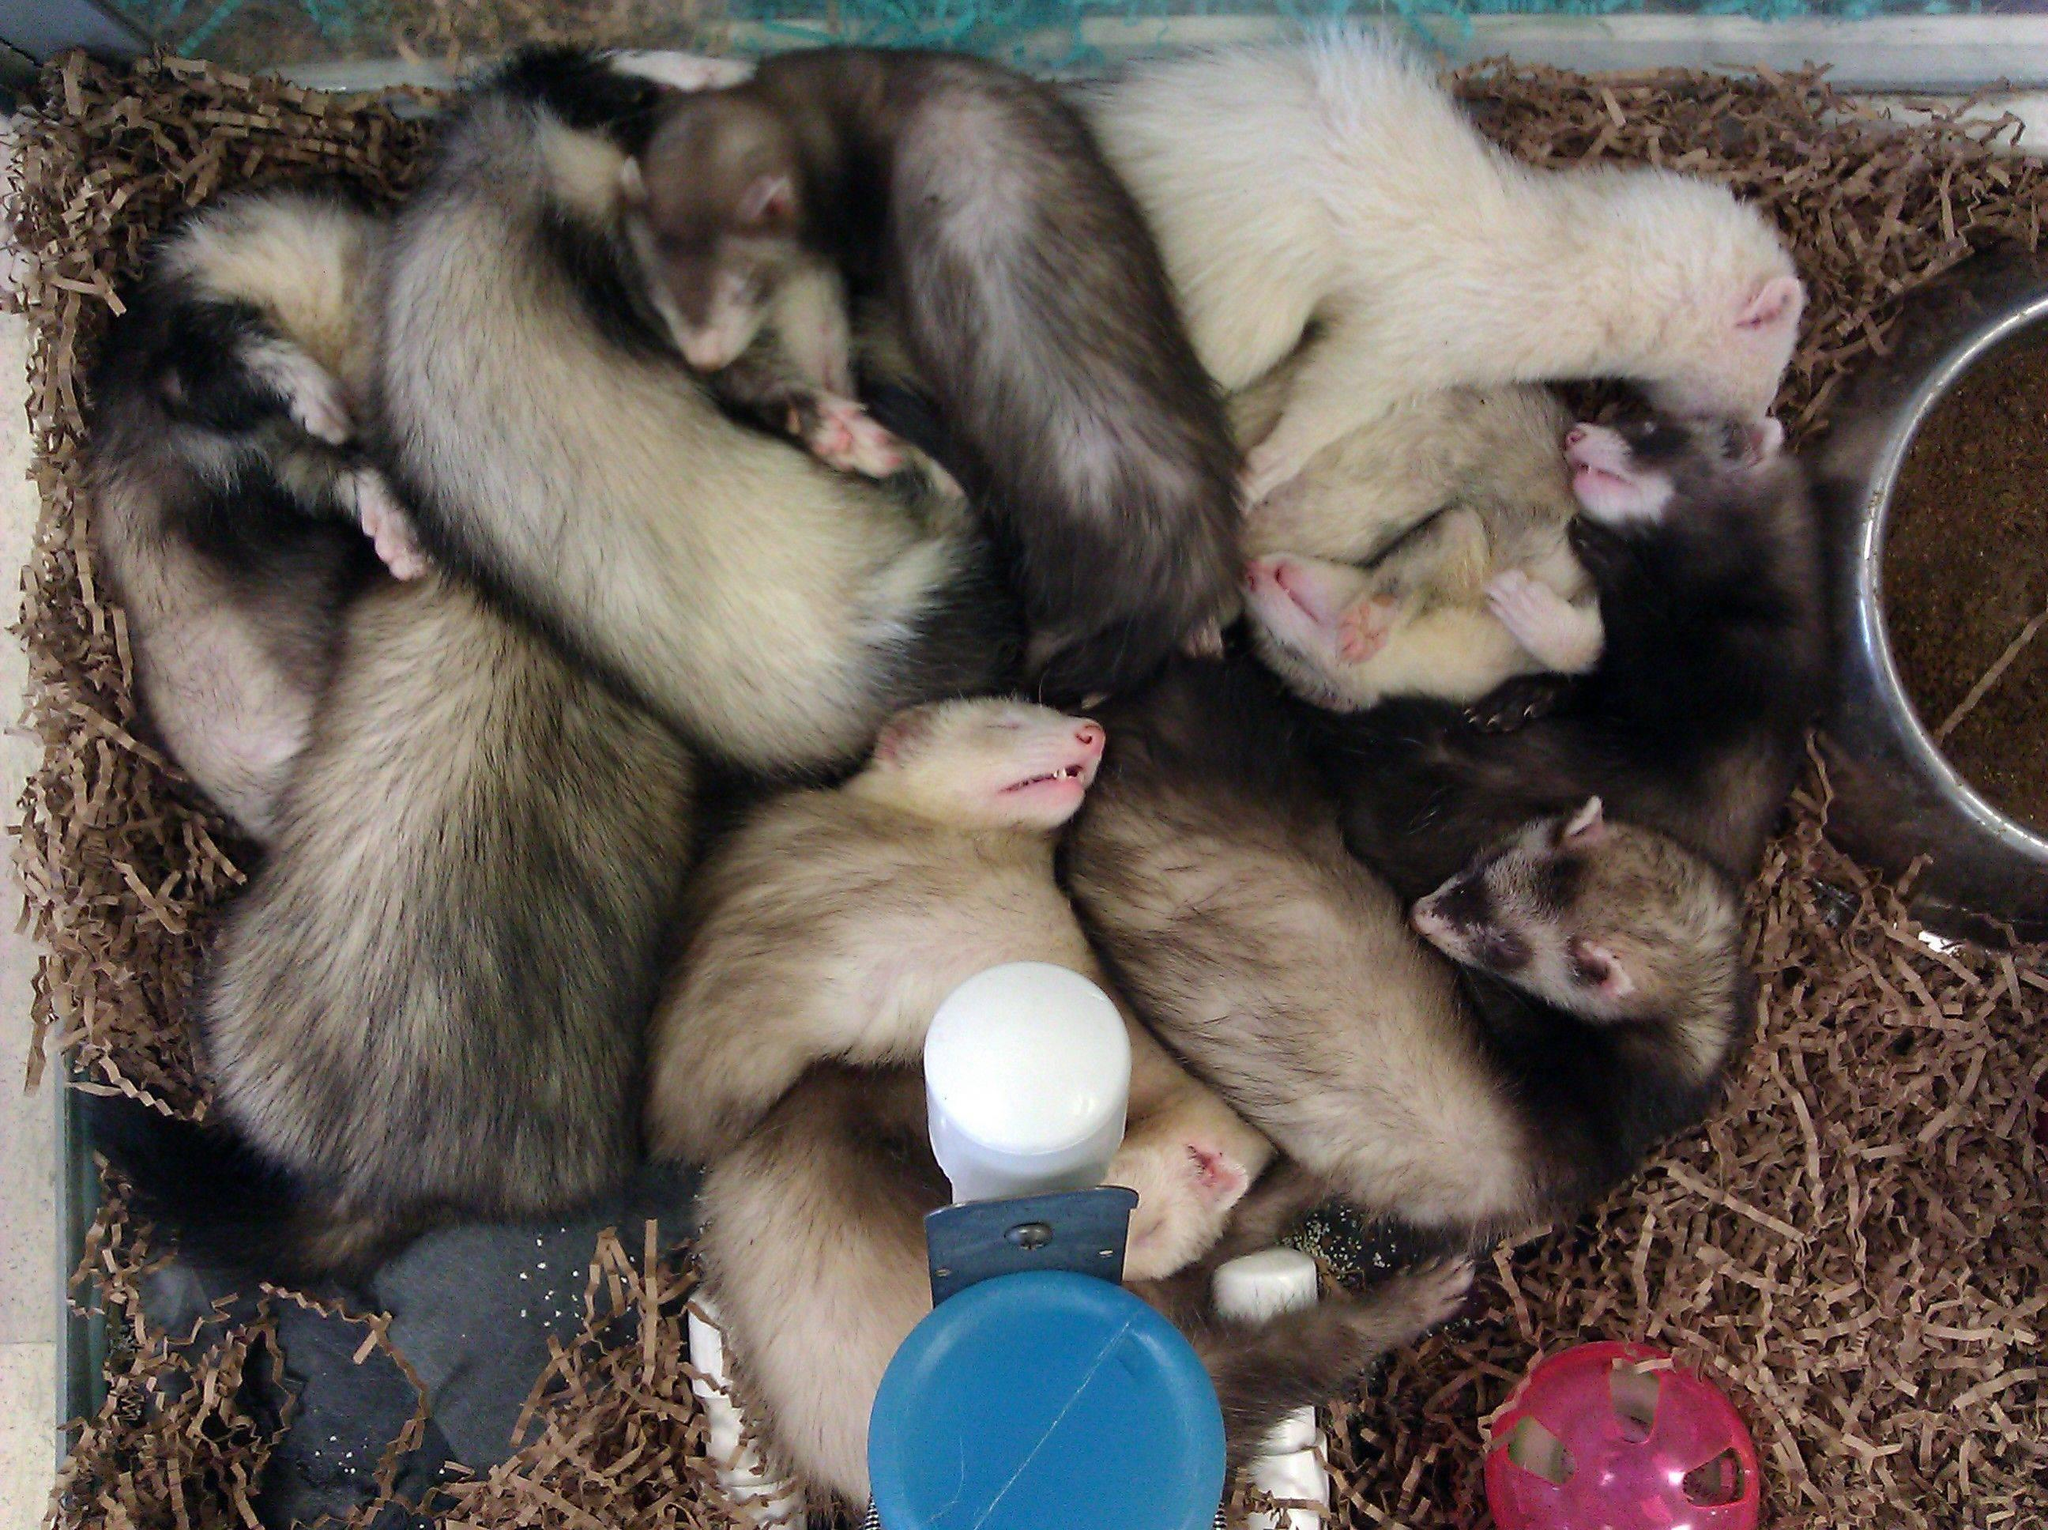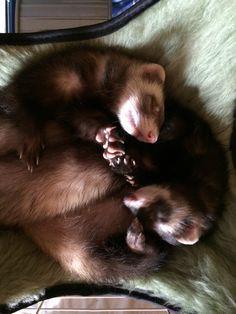The first image is the image on the left, the second image is the image on the right. For the images shown, is this caption "The animals in one of the images are near a window." true? Answer yes or no. No. The first image is the image on the left, the second image is the image on the right. Examine the images to the left and right. Is the description "All images show ferrets with their faces aligned together, and at least one image contains exactly three ferrets." accurate? Answer yes or no. No. 